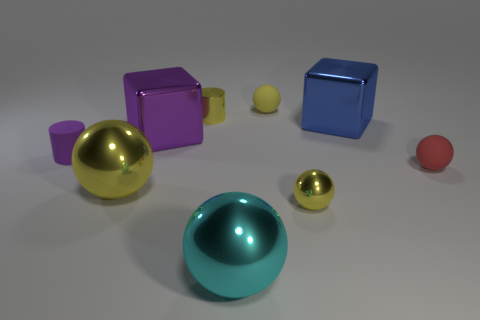How many other objects are there of the same color as the matte cylinder?
Make the answer very short. 1. There is a tiny rubber object behind the tiny metal thing that is behind the small yellow sphere that is in front of the small red thing; what color is it?
Your response must be concise. Yellow. There is another yellow matte object that is the same shape as the large yellow thing; what is its size?
Offer a terse response. Small. Are there fewer red rubber objects that are left of the large blue metallic thing than small rubber spheres on the right side of the yellow shiny cylinder?
Your response must be concise. Yes. What is the shape of the large thing that is in front of the small red rubber sphere and behind the cyan metal sphere?
Ensure brevity in your answer.  Sphere. There is a yellow cylinder that is the same material as the big cyan ball; what is its size?
Provide a succinct answer. Small. There is a matte cylinder; does it have the same color as the block on the left side of the tiny yellow rubber ball?
Ensure brevity in your answer.  Yes. There is a tiny object that is both in front of the purple metal block and behind the small red rubber object; what is its material?
Give a very brief answer. Rubber. There is a rubber thing that is the same color as the tiny metal cylinder; what size is it?
Make the answer very short. Small. Is the shape of the yellow metal object to the right of the cyan shiny ball the same as the big blue object that is behind the red sphere?
Offer a very short reply. No. 